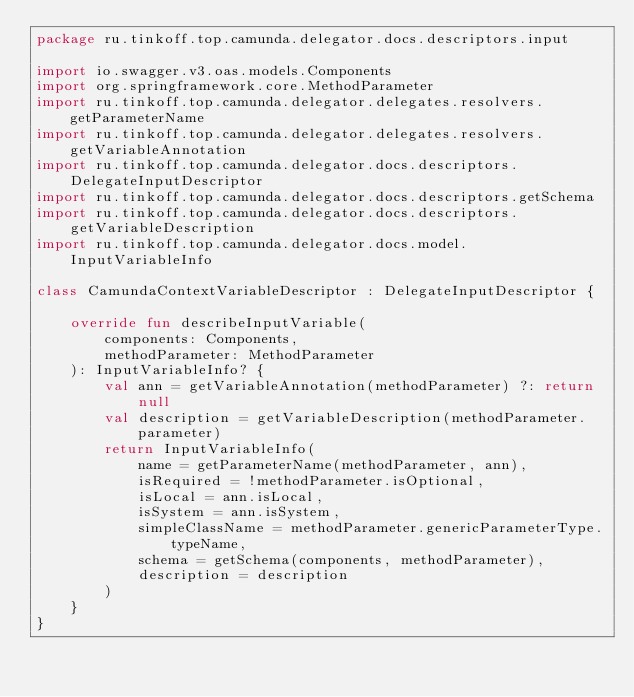Convert code to text. <code><loc_0><loc_0><loc_500><loc_500><_Kotlin_>package ru.tinkoff.top.camunda.delegator.docs.descriptors.input

import io.swagger.v3.oas.models.Components
import org.springframework.core.MethodParameter
import ru.tinkoff.top.camunda.delegator.delegates.resolvers.getParameterName
import ru.tinkoff.top.camunda.delegator.delegates.resolvers.getVariableAnnotation
import ru.tinkoff.top.camunda.delegator.docs.descriptors.DelegateInputDescriptor
import ru.tinkoff.top.camunda.delegator.docs.descriptors.getSchema
import ru.tinkoff.top.camunda.delegator.docs.descriptors.getVariableDescription
import ru.tinkoff.top.camunda.delegator.docs.model.InputVariableInfo

class CamundaContextVariableDescriptor : DelegateInputDescriptor {

    override fun describeInputVariable(
        components: Components,
        methodParameter: MethodParameter
    ): InputVariableInfo? {
        val ann = getVariableAnnotation(methodParameter) ?: return null
        val description = getVariableDescription(methodParameter.parameter)
        return InputVariableInfo(
            name = getParameterName(methodParameter, ann),
            isRequired = !methodParameter.isOptional,
            isLocal = ann.isLocal,
            isSystem = ann.isSystem,
            simpleClassName = methodParameter.genericParameterType.typeName,
            schema = getSchema(components, methodParameter),
            description = description
        )
    }
}
</code> 